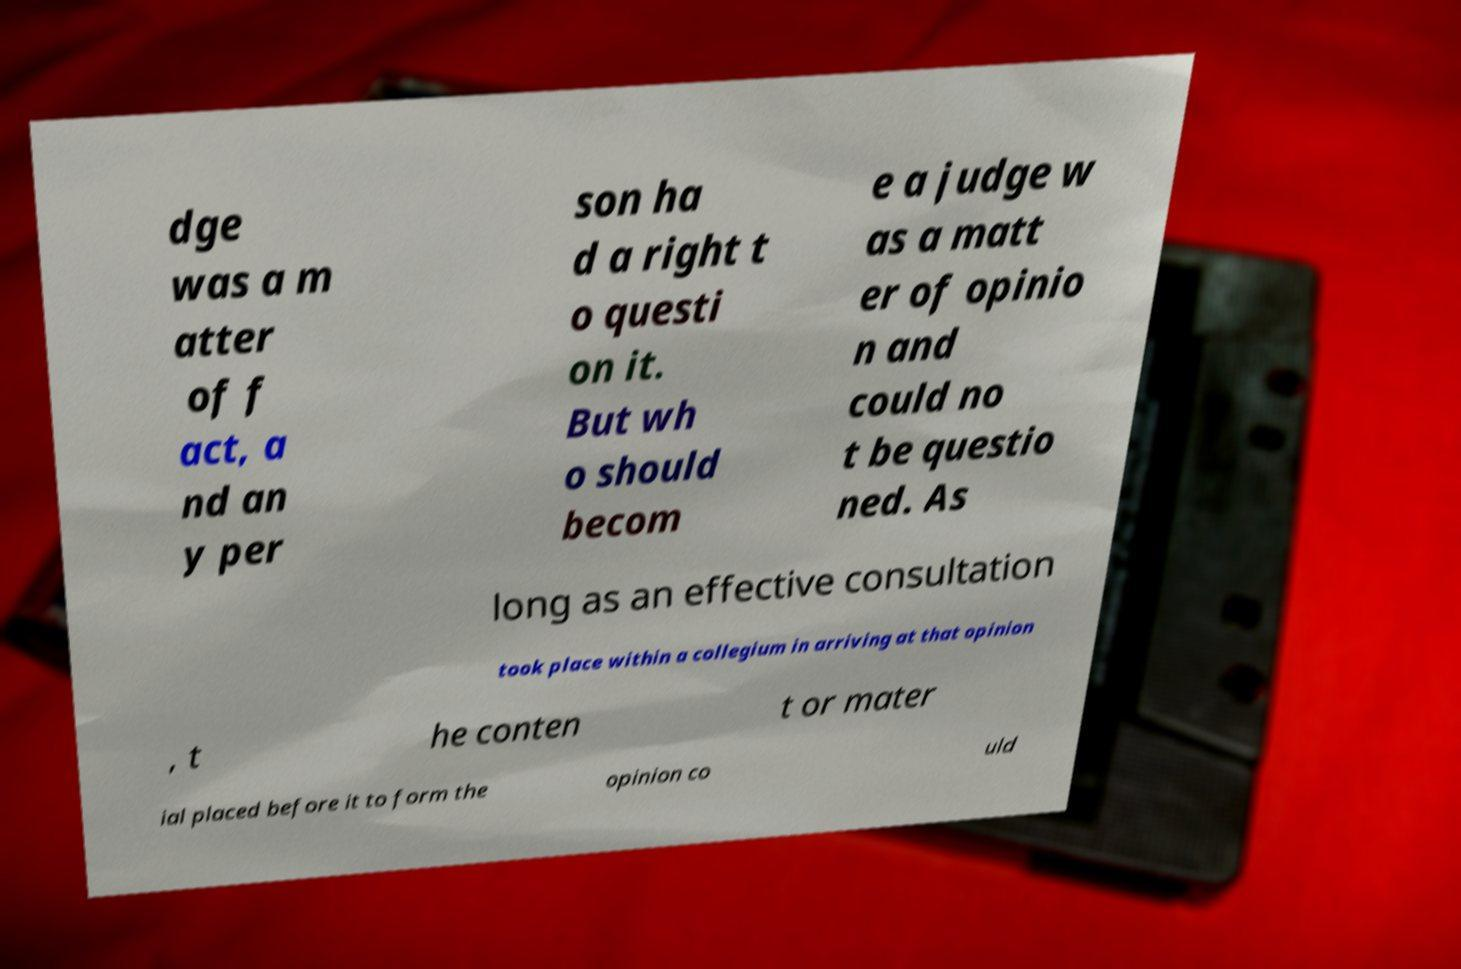Can you read and provide the text displayed in the image?This photo seems to have some interesting text. Can you extract and type it out for me? dge was a m atter of f act, a nd an y per son ha d a right t o questi on it. But wh o should becom e a judge w as a matt er of opinio n and could no t be questio ned. As long as an effective consultation took place within a collegium in arriving at that opinion , t he conten t or mater ial placed before it to form the opinion co uld 